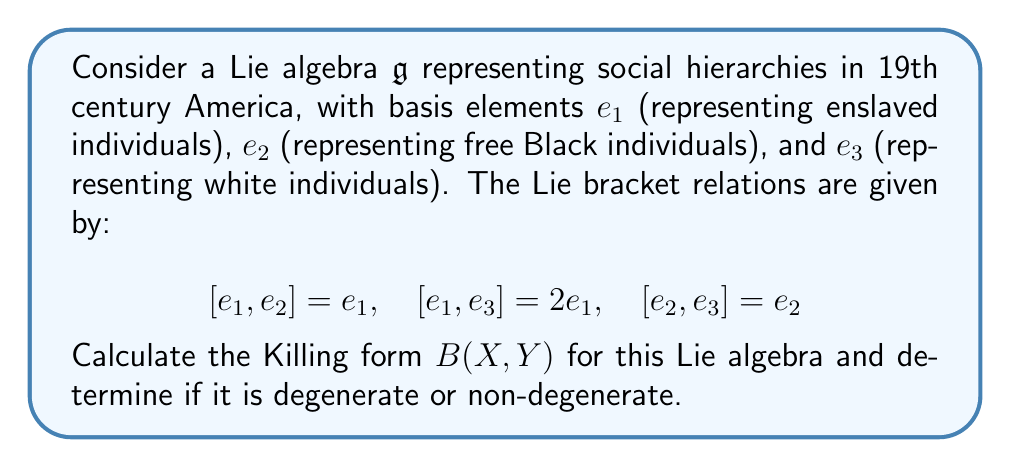Help me with this question. To calculate the Killing form for this Lie algebra, we need to follow these steps:

1) The Killing form is defined as $B(X,Y) = \text{tr}(\text{ad}_X \circ \text{ad}_Y)$, where $\text{ad}_X(Z) = [X,Z]$ for any $Z$ in the Lie algebra.

2) First, we need to find the matrix representations of $\text{ad}_{e_1}$, $\text{ad}_{e_2}$, and $\text{ad}_{e_3}$:

   $\text{ad}_{e_1} = \begin{pmatrix} 0 & 0 & 0 \\ 0 & 0 & 0 \\ 0 & 0 & 0 \end{pmatrix}$

   $\text{ad}_{e_2} = \begin{pmatrix} -1 & 0 & 0 \\ 0 & 0 & 0 \\ 0 & 0 & 0 \end{pmatrix}$

   $\text{ad}_{e_3} = \begin{pmatrix} -2 & 0 & 0 \\ 0 & -1 & 0 \\ 0 & 0 & 0 \end{pmatrix}$

3) Now, we can calculate the Killing form for each pair of basis elements:

   $B(e_1, e_1) = \text{tr}(\text{ad}_{e_1} \circ \text{ad}_{e_1}) = 0$
   $B(e_1, e_2) = \text{tr}(\text{ad}_{e_1} \circ \text{ad}_{e_2}) = 0$
   $B(e_1, e_3) = \text{tr}(\text{ad}_{e_1} \circ \text{ad}_{e_3}) = 0$
   $B(e_2, e_2) = \text{tr}(\text{ad}_{e_2} \circ \text{ad}_{e_2}) = 1$
   $B(e_2, e_3) = \text{tr}(\text{ad}_{e_2} \circ \text{ad}_{e_3}) = 2$
   $B(e_3, e_3) = \text{tr}(\text{ad}_{e_3} \circ \text{ad}_{e_3}) = 5$

4) The Killing form matrix is therefore:

   $B = \begin{pmatrix} 0 & 0 & 0 \\ 0 & 1 & 2 \\ 0 & 2 & 5 \end{pmatrix}$

5) To determine if the Killing form is degenerate or non-degenerate, we calculate the determinant of $B$:

   $\det(B) = 0 \cdot (1 \cdot 5 - 2 \cdot 2) - 0 \cdot (0 \cdot 5 - 2 \cdot 0) + 0 \cdot (0 \cdot 2 - 1 \cdot 0) = 0$

6) Since the determinant is zero, the Killing form is degenerate.

This result reflects the rigid social hierarchy of 19th century America, where the lowest social class (represented by $e_1$) had no impact on the overall structure, mirroring the lack of agency afforded to enslaved individuals in that era.
Answer: The Killing form for the given Lie algebra is:

$$B = \begin{pmatrix} 0 & 0 & 0 \\ 0 & 1 & 2 \\ 0 & 2 & 5 \end{pmatrix}$$

The Killing form is degenerate as $\det(B) = 0$. 